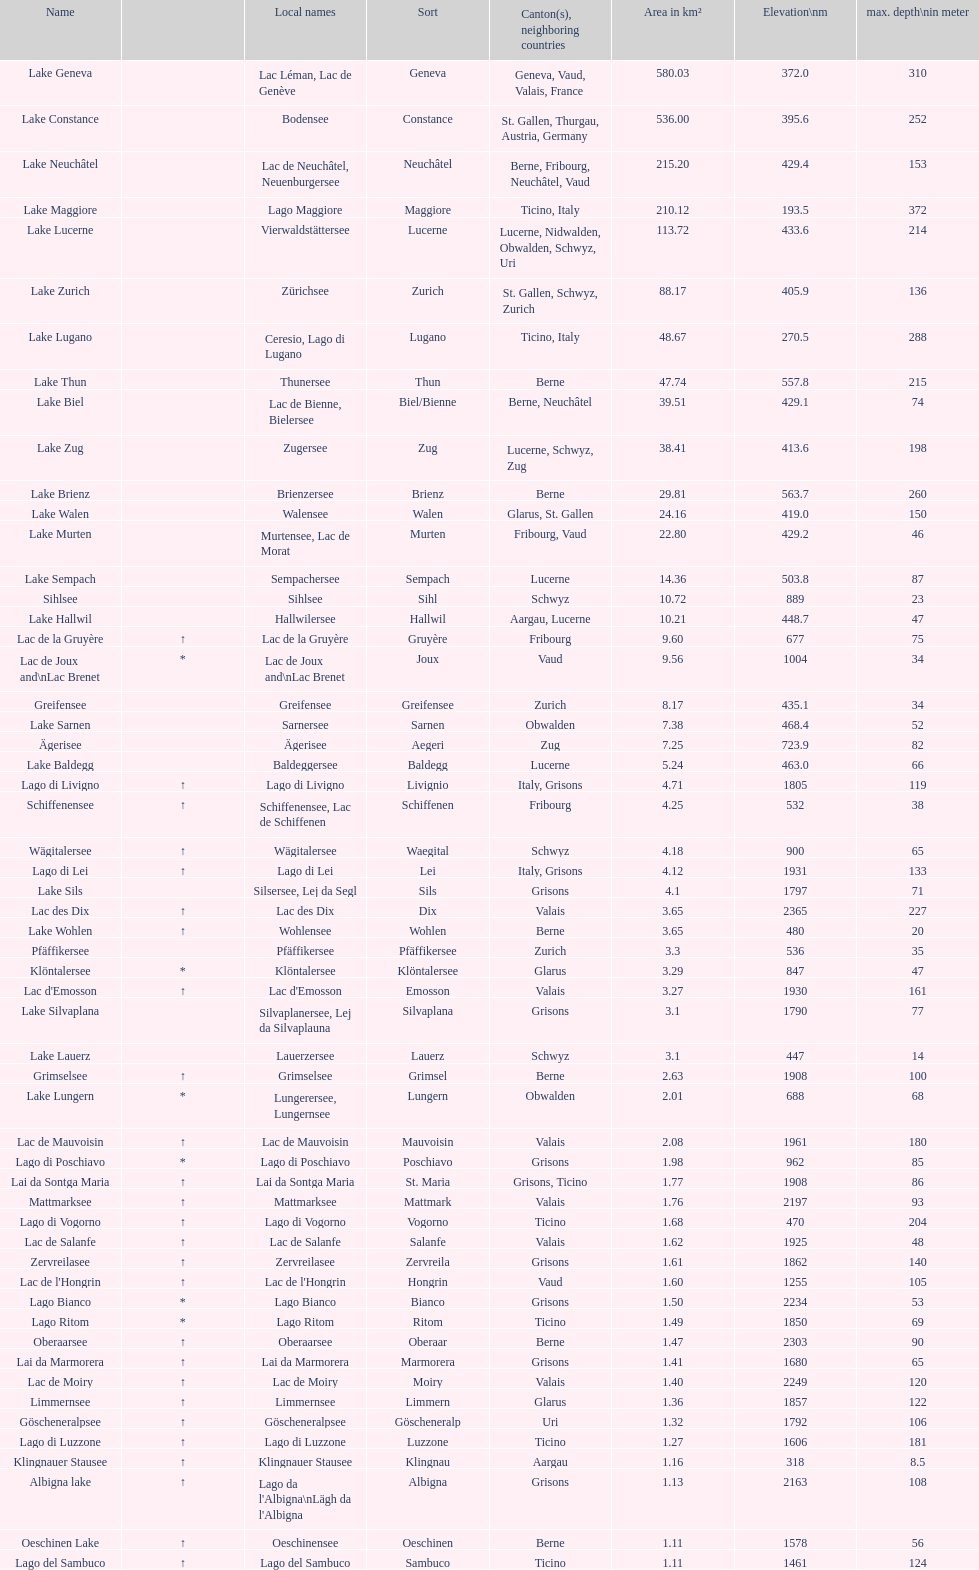Which lake holds the maximum elevation? Lac des Dix. 